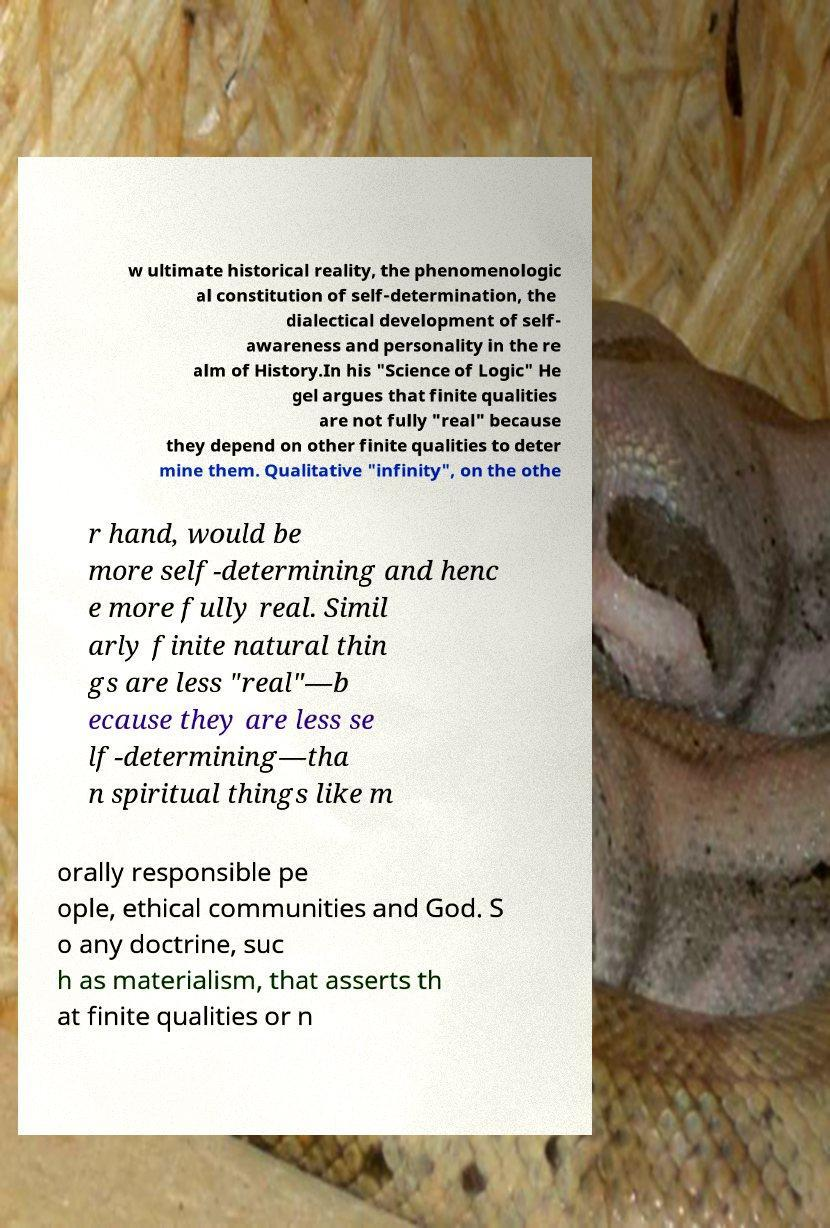Could you extract and type out the text from this image? w ultimate historical reality, the phenomenologic al constitution of self-determination, the dialectical development of self- awareness and personality in the re alm of History.In his "Science of Logic" He gel argues that finite qualities are not fully "real" because they depend on other finite qualities to deter mine them. Qualitative "infinity", on the othe r hand, would be more self-determining and henc e more fully real. Simil arly finite natural thin gs are less "real"—b ecause they are less se lf-determining—tha n spiritual things like m orally responsible pe ople, ethical communities and God. S o any doctrine, suc h as materialism, that asserts th at finite qualities or n 